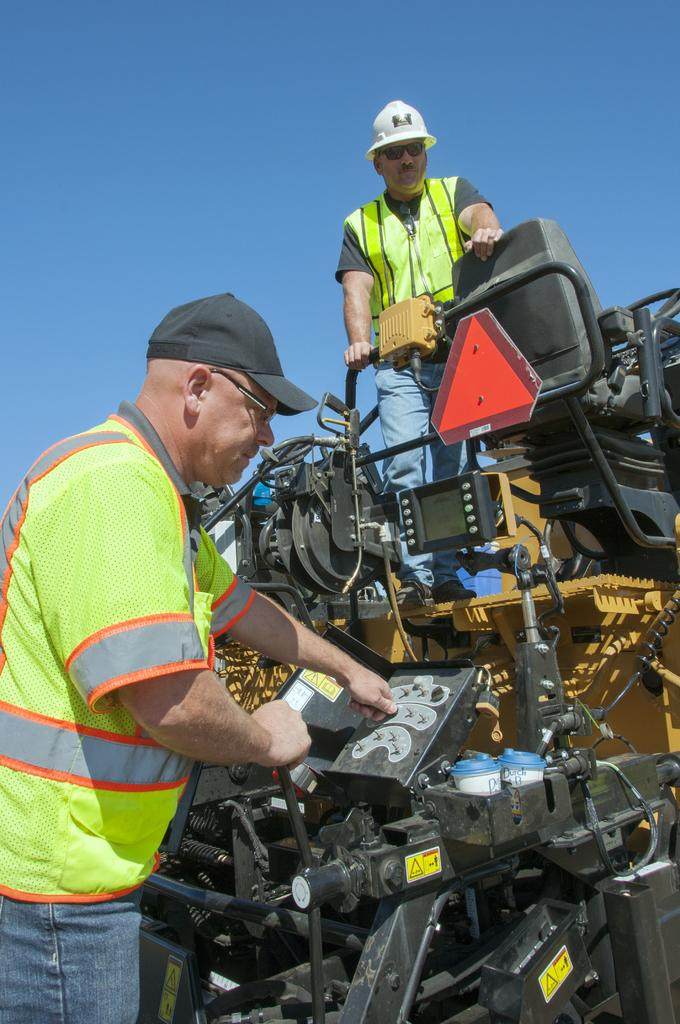How many men are standing in the image? There are two men standing in the image. What can be seen in the image besides the men? There is a vehicle with engines, a signboard, and a seat in the image. Are there any goldfish swimming in the vehicle with engines in the image? No, there are no goldfish present in the image. 